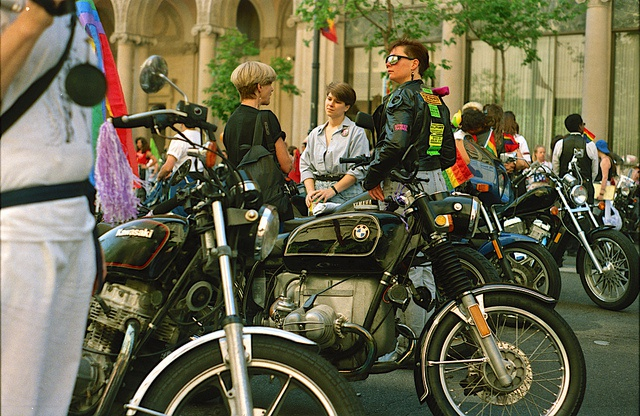Describe the objects in this image and their specific colors. I can see motorcycle in darkgreen, black, gray, and tan tones, motorcycle in darkgreen, black, ivory, and gray tones, people in darkgreen, darkgray, lightgray, and black tones, motorcycle in darkgreen, black, and white tones, and people in darkgreen, black, and gray tones in this image. 